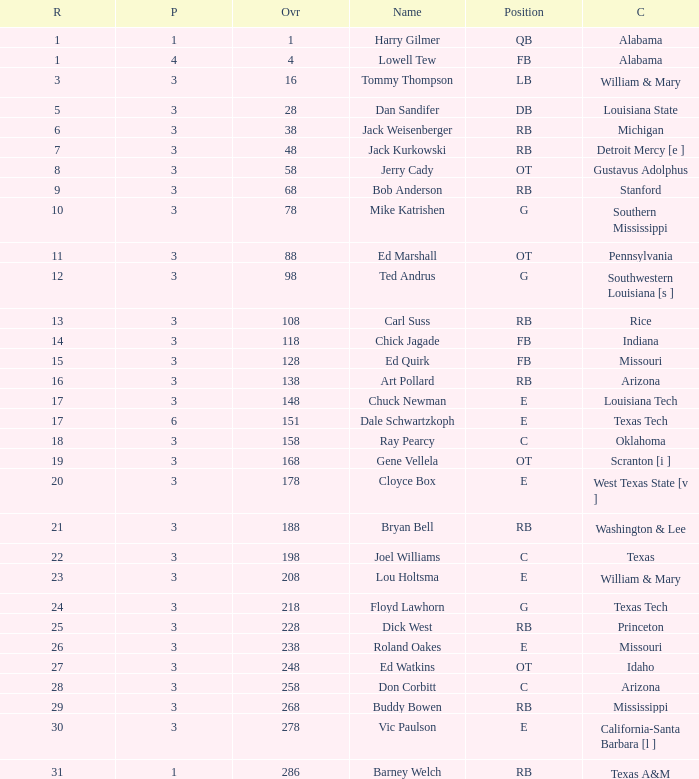Parse the table in full. {'header': ['R', 'P', 'Ovr', 'Name', 'Position', 'C'], 'rows': [['1', '1', '1', 'Harry Gilmer', 'QB', 'Alabama'], ['1', '4', '4', 'Lowell Tew', 'FB', 'Alabama'], ['3', '3', '16', 'Tommy Thompson', 'LB', 'William & Mary'], ['5', '3', '28', 'Dan Sandifer', 'DB', 'Louisiana State'], ['6', '3', '38', 'Jack Weisenberger', 'RB', 'Michigan'], ['7', '3', '48', 'Jack Kurkowski', 'RB', 'Detroit Mercy [e ]'], ['8', '3', '58', 'Jerry Cady', 'OT', 'Gustavus Adolphus'], ['9', '3', '68', 'Bob Anderson', 'RB', 'Stanford'], ['10', '3', '78', 'Mike Katrishen', 'G', 'Southern Mississippi'], ['11', '3', '88', 'Ed Marshall', 'OT', 'Pennsylvania'], ['12', '3', '98', 'Ted Andrus', 'G', 'Southwestern Louisiana [s ]'], ['13', '3', '108', 'Carl Suss', 'RB', 'Rice'], ['14', '3', '118', 'Chick Jagade', 'FB', 'Indiana'], ['15', '3', '128', 'Ed Quirk', 'FB', 'Missouri'], ['16', '3', '138', 'Art Pollard', 'RB', 'Arizona'], ['17', '3', '148', 'Chuck Newman', 'E', 'Louisiana Tech'], ['17', '6', '151', 'Dale Schwartzkoph', 'E', 'Texas Tech'], ['18', '3', '158', 'Ray Pearcy', 'C', 'Oklahoma'], ['19', '3', '168', 'Gene Vellela', 'OT', 'Scranton [i ]'], ['20', '3', '178', 'Cloyce Box', 'E', 'West Texas State [v ]'], ['21', '3', '188', 'Bryan Bell', 'RB', 'Washington & Lee'], ['22', '3', '198', 'Joel Williams', 'C', 'Texas'], ['23', '3', '208', 'Lou Holtsma', 'E', 'William & Mary'], ['24', '3', '218', 'Floyd Lawhorn', 'G', 'Texas Tech'], ['25', '3', '228', 'Dick West', 'RB', 'Princeton'], ['26', '3', '238', 'Roland Oakes', 'E', 'Missouri'], ['27', '3', '248', 'Ed Watkins', 'OT', 'Idaho'], ['28', '3', '258', 'Don Corbitt', 'C', 'Arizona'], ['29', '3', '268', 'Buddy Bowen', 'RB', 'Mississippi'], ['30', '3', '278', 'Vic Paulson', 'E', 'California-Santa Barbara [l ]'], ['31', '1', '286', 'Barney Welch', 'RB', 'Texas A&M']]} What is stanford's average overall? 68.0. 